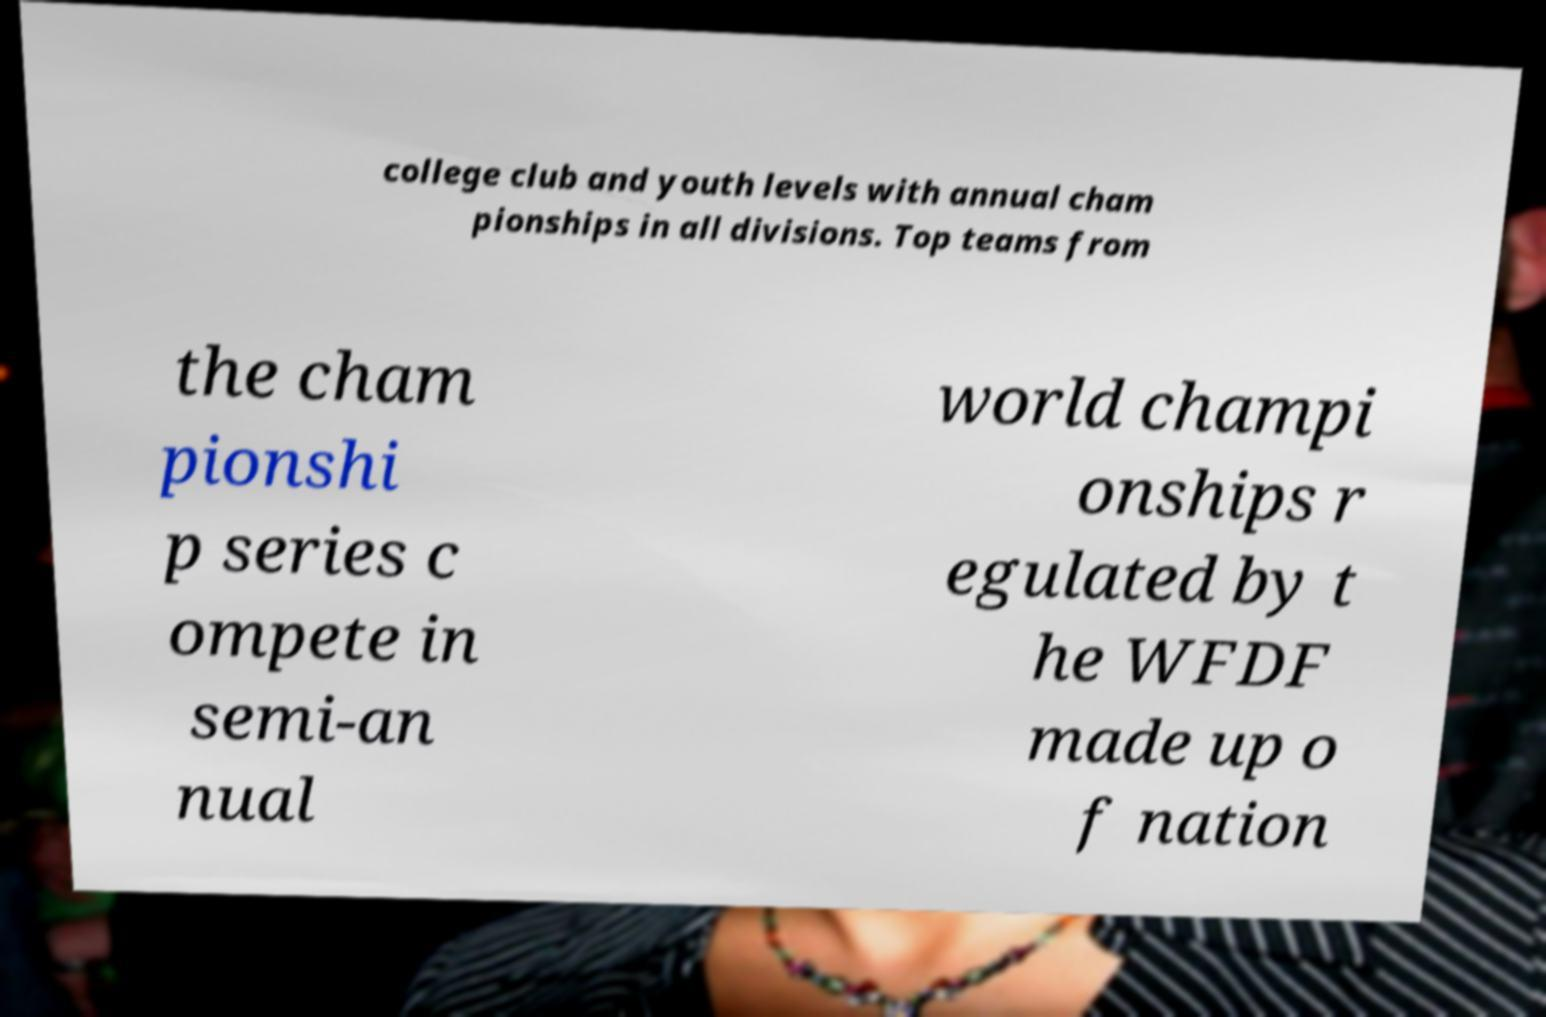For documentation purposes, I need the text within this image transcribed. Could you provide that? college club and youth levels with annual cham pionships in all divisions. Top teams from the cham pionshi p series c ompete in semi-an nual world champi onships r egulated by t he WFDF made up o f nation 